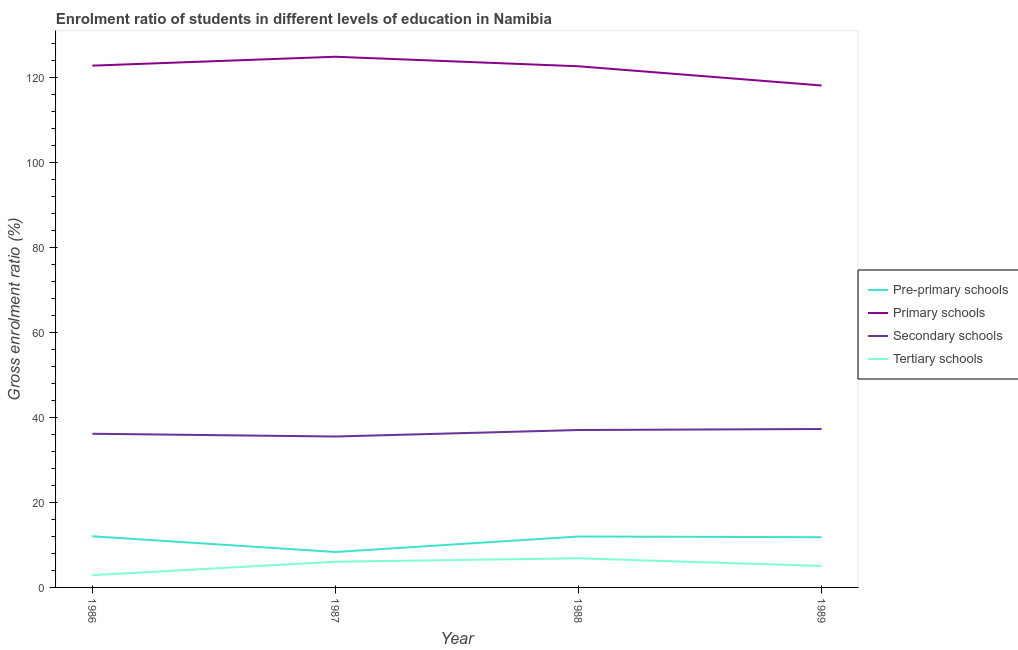How many different coloured lines are there?
Make the answer very short. 4. Does the line corresponding to gross enrolment ratio in primary schools intersect with the line corresponding to gross enrolment ratio in secondary schools?
Keep it short and to the point. No. What is the gross enrolment ratio in secondary schools in 1986?
Offer a very short reply. 36.14. Across all years, what is the maximum gross enrolment ratio in primary schools?
Provide a succinct answer. 124.79. Across all years, what is the minimum gross enrolment ratio in tertiary schools?
Provide a succinct answer. 2.88. In which year was the gross enrolment ratio in tertiary schools minimum?
Make the answer very short. 1986. What is the total gross enrolment ratio in primary schools in the graph?
Ensure brevity in your answer.  488.06. What is the difference between the gross enrolment ratio in pre-primary schools in 1986 and that in 1988?
Offer a terse response. 0.05. What is the difference between the gross enrolment ratio in pre-primary schools in 1989 and the gross enrolment ratio in primary schools in 1987?
Make the answer very short. -112.97. What is the average gross enrolment ratio in primary schools per year?
Provide a succinct answer. 122.01. In the year 1986, what is the difference between the gross enrolment ratio in pre-primary schools and gross enrolment ratio in secondary schools?
Your answer should be very brief. -24.11. What is the ratio of the gross enrolment ratio in secondary schools in 1986 to that in 1989?
Make the answer very short. 0.97. What is the difference between the highest and the second highest gross enrolment ratio in secondary schools?
Ensure brevity in your answer.  0.24. What is the difference between the highest and the lowest gross enrolment ratio in primary schools?
Provide a succinct answer. 6.76. Is the sum of the gross enrolment ratio in primary schools in 1987 and 1989 greater than the maximum gross enrolment ratio in pre-primary schools across all years?
Your answer should be very brief. Yes. Is it the case that in every year, the sum of the gross enrolment ratio in primary schools and gross enrolment ratio in tertiary schools is greater than the sum of gross enrolment ratio in pre-primary schools and gross enrolment ratio in secondary schools?
Provide a short and direct response. Yes. Is the gross enrolment ratio in pre-primary schools strictly greater than the gross enrolment ratio in primary schools over the years?
Offer a very short reply. No. How many years are there in the graph?
Keep it short and to the point. 4. What is the difference between two consecutive major ticks on the Y-axis?
Your answer should be compact. 20. Are the values on the major ticks of Y-axis written in scientific E-notation?
Provide a succinct answer. No. Does the graph contain any zero values?
Offer a terse response. No. Does the graph contain grids?
Provide a succinct answer. No. How many legend labels are there?
Your response must be concise. 4. What is the title of the graph?
Ensure brevity in your answer.  Enrolment ratio of students in different levels of education in Namibia. Does "Natural Gas" appear as one of the legend labels in the graph?
Offer a terse response. No. What is the label or title of the Y-axis?
Provide a succinct answer. Gross enrolment ratio (%). What is the Gross enrolment ratio (%) in Pre-primary schools in 1986?
Offer a very short reply. 12.03. What is the Gross enrolment ratio (%) of Primary schools in 1986?
Offer a very short reply. 122.7. What is the Gross enrolment ratio (%) of Secondary schools in 1986?
Your response must be concise. 36.14. What is the Gross enrolment ratio (%) of Tertiary schools in 1986?
Offer a very short reply. 2.88. What is the Gross enrolment ratio (%) of Pre-primary schools in 1987?
Provide a short and direct response. 8.33. What is the Gross enrolment ratio (%) of Primary schools in 1987?
Provide a succinct answer. 124.79. What is the Gross enrolment ratio (%) in Secondary schools in 1987?
Offer a terse response. 35.49. What is the Gross enrolment ratio (%) of Tertiary schools in 1987?
Offer a very short reply. 6.05. What is the Gross enrolment ratio (%) of Pre-primary schools in 1988?
Give a very brief answer. 11.97. What is the Gross enrolment ratio (%) of Primary schools in 1988?
Your answer should be compact. 122.55. What is the Gross enrolment ratio (%) in Secondary schools in 1988?
Ensure brevity in your answer.  37.01. What is the Gross enrolment ratio (%) of Tertiary schools in 1988?
Your response must be concise. 6.85. What is the Gross enrolment ratio (%) of Pre-primary schools in 1989?
Offer a terse response. 11.81. What is the Gross enrolment ratio (%) in Primary schools in 1989?
Give a very brief answer. 118.03. What is the Gross enrolment ratio (%) in Secondary schools in 1989?
Make the answer very short. 37.25. What is the Gross enrolment ratio (%) in Tertiary schools in 1989?
Give a very brief answer. 5.05. Across all years, what is the maximum Gross enrolment ratio (%) in Pre-primary schools?
Provide a succinct answer. 12.03. Across all years, what is the maximum Gross enrolment ratio (%) of Primary schools?
Ensure brevity in your answer.  124.79. Across all years, what is the maximum Gross enrolment ratio (%) of Secondary schools?
Provide a short and direct response. 37.25. Across all years, what is the maximum Gross enrolment ratio (%) in Tertiary schools?
Give a very brief answer. 6.85. Across all years, what is the minimum Gross enrolment ratio (%) of Pre-primary schools?
Provide a succinct answer. 8.33. Across all years, what is the minimum Gross enrolment ratio (%) of Primary schools?
Provide a short and direct response. 118.03. Across all years, what is the minimum Gross enrolment ratio (%) of Secondary schools?
Keep it short and to the point. 35.49. Across all years, what is the minimum Gross enrolment ratio (%) of Tertiary schools?
Offer a very short reply. 2.88. What is the total Gross enrolment ratio (%) of Pre-primary schools in the graph?
Ensure brevity in your answer.  44.14. What is the total Gross enrolment ratio (%) of Primary schools in the graph?
Ensure brevity in your answer.  488.06. What is the total Gross enrolment ratio (%) of Secondary schools in the graph?
Provide a succinct answer. 145.89. What is the total Gross enrolment ratio (%) of Tertiary schools in the graph?
Offer a very short reply. 20.82. What is the difference between the Gross enrolment ratio (%) in Pre-primary schools in 1986 and that in 1987?
Your response must be concise. 3.7. What is the difference between the Gross enrolment ratio (%) of Primary schools in 1986 and that in 1987?
Offer a terse response. -2.09. What is the difference between the Gross enrolment ratio (%) of Secondary schools in 1986 and that in 1987?
Offer a very short reply. 0.65. What is the difference between the Gross enrolment ratio (%) of Tertiary schools in 1986 and that in 1987?
Your answer should be compact. -3.16. What is the difference between the Gross enrolment ratio (%) in Pre-primary schools in 1986 and that in 1988?
Offer a terse response. 0.05. What is the difference between the Gross enrolment ratio (%) of Primary schools in 1986 and that in 1988?
Keep it short and to the point. 0.15. What is the difference between the Gross enrolment ratio (%) in Secondary schools in 1986 and that in 1988?
Make the answer very short. -0.88. What is the difference between the Gross enrolment ratio (%) of Tertiary schools in 1986 and that in 1988?
Your response must be concise. -3.97. What is the difference between the Gross enrolment ratio (%) of Pre-primary schools in 1986 and that in 1989?
Offer a terse response. 0.22. What is the difference between the Gross enrolment ratio (%) of Primary schools in 1986 and that in 1989?
Ensure brevity in your answer.  4.67. What is the difference between the Gross enrolment ratio (%) in Secondary schools in 1986 and that in 1989?
Make the answer very short. -1.12. What is the difference between the Gross enrolment ratio (%) of Tertiary schools in 1986 and that in 1989?
Your answer should be compact. -2.17. What is the difference between the Gross enrolment ratio (%) in Pre-primary schools in 1987 and that in 1988?
Offer a terse response. -3.64. What is the difference between the Gross enrolment ratio (%) of Primary schools in 1987 and that in 1988?
Your response must be concise. 2.24. What is the difference between the Gross enrolment ratio (%) in Secondary schools in 1987 and that in 1988?
Your answer should be very brief. -1.53. What is the difference between the Gross enrolment ratio (%) in Tertiary schools in 1987 and that in 1988?
Make the answer very short. -0.8. What is the difference between the Gross enrolment ratio (%) in Pre-primary schools in 1987 and that in 1989?
Your response must be concise. -3.48. What is the difference between the Gross enrolment ratio (%) of Primary schools in 1987 and that in 1989?
Offer a very short reply. 6.76. What is the difference between the Gross enrolment ratio (%) in Secondary schools in 1987 and that in 1989?
Offer a very short reply. -1.77. What is the difference between the Gross enrolment ratio (%) of Tertiary schools in 1987 and that in 1989?
Your answer should be very brief. 1. What is the difference between the Gross enrolment ratio (%) in Pre-primary schools in 1988 and that in 1989?
Provide a short and direct response. 0.16. What is the difference between the Gross enrolment ratio (%) of Primary schools in 1988 and that in 1989?
Provide a short and direct response. 4.52. What is the difference between the Gross enrolment ratio (%) of Secondary schools in 1988 and that in 1989?
Offer a very short reply. -0.24. What is the difference between the Gross enrolment ratio (%) in Tertiary schools in 1988 and that in 1989?
Your response must be concise. 1.8. What is the difference between the Gross enrolment ratio (%) in Pre-primary schools in 1986 and the Gross enrolment ratio (%) in Primary schools in 1987?
Make the answer very short. -112.76. What is the difference between the Gross enrolment ratio (%) in Pre-primary schools in 1986 and the Gross enrolment ratio (%) in Secondary schools in 1987?
Give a very brief answer. -23.46. What is the difference between the Gross enrolment ratio (%) of Pre-primary schools in 1986 and the Gross enrolment ratio (%) of Tertiary schools in 1987?
Offer a very short reply. 5.98. What is the difference between the Gross enrolment ratio (%) in Primary schools in 1986 and the Gross enrolment ratio (%) in Secondary schools in 1987?
Give a very brief answer. 87.21. What is the difference between the Gross enrolment ratio (%) in Primary schools in 1986 and the Gross enrolment ratio (%) in Tertiary schools in 1987?
Provide a short and direct response. 116.65. What is the difference between the Gross enrolment ratio (%) in Secondary schools in 1986 and the Gross enrolment ratio (%) in Tertiary schools in 1987?
Ensure brevity in your answer.  30.09. What is the difference between the Gross enrolment ratio (%) in Pre-primary schools in 1986 and the Gross enrolment ratio (%) in Primary schools in 1988?
Your answer should be compact. -110.52. What is the difference between the Gross enrolment ratio (%) in Pre-primary schools in 1986 and the Gross enrolment ratio (%) in Secondary schools in 1988?
Make the answer very short. -24.99. What is the difference between the Gross enrolment ratio (%) in Pre-primary schools in 1986 and the Gross enrolment ratio (%) in Tertiary schools in 1988?
Offer a terse response. 5.18. What is the difference between the Gross enrolment ratio (%) of Primary schools in 1986 and the Gross enrolment ratio (%) of Secondary schools in 1988?
Give a very brief answer. 85.68. What is the difference between the Gross enrolment ratio (%) in Primary schools in 1986 and the Gross enrolment ratio (%) in Tertiary schools in 1988?
Provide a short and direct response. 115.85. What is the difference between the Gross enrolment ratio (%) in Secondary schools in 1986 and the Gross enrolment ratio (%) in Tertiary schools in 1988?
Ensure brevity in your answer.  29.29. What is the difference between the Gross enrolment ratio (%) in Pre-primary schools in 1986 and the Gross enrolment ratio (%) in Primary schools in 1989?
Your answer should be very brief. -106. What is the difference between the Gross enrolment ratio (%) in Pre-primary schools in 1986 and the Gross enrolment ratio (%) in Secondary schools in 1989?
Provide a succinct answer. -25.22. What is the difference between the Gross enrolment ratio (%) in Pre-primary schools in 1986 and the Gross enrolment ratio (%) in Tertiary schools in 1989?
Offer a very short reply. 6.98. What is the difference between the Gross enrolment ratio (%) of Primary schools in 1986 and the Gross enrolment ratio (%) of Secondary schools in 1989?
Offer a very short reply. 85.44. What is the difference between the Gross enrolment ratio (%) in Primary schools in 1986 and the Gross enrolment ratio (%) in Tertiary schools in 1989?
Give a very brief answer. 117.65. What is the difference between the Gross enrolment ratio (%) of Secondary schools in 1986 and the Gross enrolment ratio (%) of Tertiary schools in 1989?
Give a very brief answer. 31.09. What is the difference between the Gross enrolment ratio (%) in Pre-primary schools in 1987 and the Gross enrolment ratio (%) in Primary schools in 1988?
Make the answer very short. -114.22. What is the difference between the Gross enrolment ratio (%) of Pre-primary schools in 1987 and the Gross enrolment ratio (%) of Secondary schools in 1988?
Make the answer very short. -28.68. What is the difference between the Gross enrolment ratio (%) in Pre-primary schools in 1987 and the Gross enrolment ratio (%) in Tertiary schools in 1988?
Keep it short and to the point. 1.48. What is the difference between the Gross enrolment ratio (%) of Primary schools in 1987 and the Gross enrolment ratio (%) of Secondary schools in 1988?
Your answer should be compact. 87.77. What is the difference between the Gross enrolment ratio (%) in Primary schools in 1987 and the Gross enrolment ratio (%) in Tertiary schools in 1988?
Your answer should be compact. 117.94. What is the difference between the Gross enrolment ratio (%) in Secondary schools in 1987 and the Gross enrolment ratio (%) in Tertiary schools in 1988?
Your response must be concise. 28.64. What is the difference between the Gross enrolment ratio (%) in Pre-primary schools in 1987 and the Gross enrolment ratio (%) in Primary schools in 1989?
Ensure brevity in your answer.  -109.7. What is the difference between the Gross enrolment ratio (%) of Pre-primary schools in 1987 and the Gross enrolment ratio (%) of Secondary schools in 1989?
Provide a short and direct response. -28.92. What is the difference between the Gross enrolment ratio (%) of Pre-primary schools in 1987 and the Gross enrolment ratio (%) of Tertiary schools in 1989?
Give a very brief answer. 3.28. What is the difference between the Gross enrolment ratio (%) of Primary schools in 1987 and the Gross enrolment ratio (%) of Secondary schools in 1989?
Your response must be concise. 87.53. What is the difference between the Gross enrolment ratio (%) in Primary schools in 1987 and the Gross enrolment ratio (%) in Tertiary schools in 1989?
Provide a succinct answer. 119.74. What is the difference between the Gross enrolment ratio (%) in Secondary schools in 1987 and the Gross enrolment ratio (%) in Tertiary schools in 1989?
Provide a short and direct response. 30.44. What is the difference between the Gross enrolment ratio (%) of Pre-primary schools in 1988 and the Gross enrolment ratio (%) of Primary schools in 1989?
Make the answer very short. -106.05. What is the difference between the Gross enrolment ratio (%) in Pre-primary schools in 1988 and the Gross enrolment ratio (%) in Secondary schools in 1989?
Your answer should be compact. -25.28. What is the difference between the Gross enrolment ratio (%) in Pre-primary schools in 1988 and the Gross enrolment ratio (%) in Tertiary schools in 1989?
Keep it short and to the point. 6.92. What is the difference between the Gross enrolment ratio (%) in Primary schools in 1988 and the Gross enrolment ratio (%) in Secondary schools in 1989?
Your answer should be compact. 85.29. What is the difference between the Gross enrolment ratio (%) in Primary schools in 1988 and the Gross enrolment ratio (%) in Tertiary schools in 1989?
Your answer should be compact. 117.5. What is the difference between the Gross enrolment ratio (%) of Secondary schools in 1988 and the Gross enrolment ratio (%) of Tertiary schools in 1989?
Ensure brevity in your answer.  31.96. What is the average Gross enrolment ratio (%) of Pre-primary schools per year?
Provide a succinct answer. 11.04. What is the average Gross enrolment ratio (%) of Primary schools per year?
Provide a succinct answer. 122.01. What is the average Gross enrolment ratio (%) in Secondary schools per year?
Your answer should be very brief. 36.47. What is the average Gross enrolment ratio (%) of Tertiary schools per year?
Your answer should be very brief. 5.21. In the year 1986, what is the difference between the Gross enrolment ratio (%) in Pre-primary schools and Gross enrolment ratio (%) in Primary schools?
Keep it short and to the point. -110.67. In the year 1986, what is the difference between the Gross enrolment ratio (%) in Pre-primary schools and Gross enrolment ratio (%) in Secondary schools?
Give a very brief answer. -24.11. In the year 1986, what is the difference between the Gross enrolment ratio (%) in Pre-primary schools and Gross enrolment ratio (%) in Tertiary schools?
Offer a terse response. 9.15. In the year 1986, what is the difference between the Gross enrolment ratio (%) in Primary schools and Gross enrolment ratio (%) in Secondary schools?
Keep it short and to the point. 86.56. In the year 1986, what is the difference between the Gross enrolment ratio (%) of Primary schools and Gross enrolment ratio (%) of Tertiary schools?
Offer a very short reply. 119.81. In the year 1986, what is the difference between the Gross enrolment ratio (%) of Secondary schools and Gross enrolment ratio (%) of Tertiary schools?
Make the answer very short. 33.26. In the year 1987, what is the difference between the Gross enrolment ratio (%) in Pre-primary schools and Gross enrolment ratio (%) in Primary schools?
Your answer should be compact. -116.46. In the year 1987, what is the difference between the Gross enrolment ratio (%) in Pre-primary schools and Gross enrolment ratio (%) in Secondary schools?
Your answer should be very brief. -27.16. In the year 1987, what is the difference between the Gross enrolment ratio (%) of Pre-primary schools and Gross enrolment ratio (%) of Tertiary schools?
Keep it short and to the point. 2.28. In the year 1987, what is the difference between the Gross enrolment ratio (%) of Primary schools and Gross enrolment ratio (%) of Secondary schools?
Give a very brief answer. 89.3. In the year 1987, what is the difference between the Gross enrolment ratio (%) of Primary schools and Gross enrolment ratio (%) of Tertiary schools?
Provide a short and direct response. 118.74. In the year 1987, what is the difference between the Gross enrolment ratio (%) in Secondary schools and Gross enrolment ratio (%) in Tertiary schools?
Your response must be concise. 29.44. In the year 1988, what is the difference between the Gross enrolment ratio (%) of Pre-primary schools and Gross enrolment ratio (%) of Primary schools?
Ensure brevity in your answer.  -110.57. In the year 1988, what is the difference between the Gross enrolment ratio (%) in Pre-primary schools and Gross enrolment ratio (%) in Secondary schools?
Keep it short and to the point. -25.04. In the year 1988, what is the difference between the Gross enrolment ratio (%) in Pre-primary schools and Gross enrolment ratio (%) in Tertiary schools?
Offer a very short reply. 5.13. In the year 1988, what is the difference between the Gross enrolment ratio (%) of Primary schools and Gross enrolment ratio (%) of Secondary schools?
Your answer should be compact. 85.53. In the year 1988, what is the difference between the Gross enrolment ratio (%) of Primary schools and Gross enrolment ratio (%) of Tertiary schools?
Your answer should be very brief. 115.7. In the year 1988, what is the difference between the Gross enrolment ratio (%) of Secondary schools and Gross enrolment ratio (%) of Tertiary schools?
Offer a very short reply. 30.17. In the year 1989, what is the difference between the Gross enrolment ratio (%) in Pre-primary schools and Gross enrolment ratio (%) in Primary schools?
Keep it short and to the point. -106.22. In the year 1989, what is the difference between the Gross enrolment ratio (%) of Pre-primary schools and Gross enrolment ratio (%) of Secondary schools?
Offer a very short reply. -25.44. In the year 1989, what is the difference between the Gross enrolment ratio (%) of Pre-primary schools and Gross enrolment ratio (%) of Tertiary schools?
Ensure brevity in your answer.  6.76. In the year 1989, what is the difference between the Gross enrolment ratio (%) in Primary schools and Gross enrolment ratio (%) in Secondary schools?
Your answer should be compact. 80.78. In the year 1989, what is the difference between the Gross enrolment ratio (%) of Primary schools and Gross enrolment ratio (%) of Tertiary schools?
Provide a short and direct response. 112.98. In the year 1989, what is the difference between the Gross enrolment ratio (%) of Secondary schools and Gross enrolment ratio (%) of Tertiary schools?
Your answer should be compact. 32.2. What is the ratio of the Gross enrolment ratio (%) in Pre-primary schools in 1986 to that in 1987?
Your response must be concise. 1.44. What is the ratio of the Gross enrolment ratio (%) of Primary schools in 1986 to that in 1987?
Keep it short and to the point. 0.98. What is the ratio of the Gross enrolment ratio (%) in Secondary schools in 1986 to that in 1987?
Offer a very short reply. 1.02. What is the ratio of the Gross enrolment ratio (%) of Tertiary schools in 1986 to that in 1987?
Provide a succinct answer. 0.48. What is the ratio of the Gross enrolment ratio (%) of Pre-primary schools in 1986 to that in 1988?
Your response must be concise. 1. What is the ratio of the Gross enrolment ratio (%) of Primary schools in 1986 to that in 1988?
Your answer should be very brief. 1. What is the ratio of the Gross enrolment ratio (%) of Secondary schools in 1986 to that in 1988?
Offer a very short reply. 0.98. What is the ratio of the Gross enrolment ratio (%) of Tertiary schools in 1986 to that in 1988?
Keep it short and to the point. 0.42. What is the ratio of the Gross enrolment ratio (%) of Pre-primary schools in 1986 to that in 1989?
Offer a terse response. 1.02. What is the ratio of the Gross enrolment ratio (%) of Primary schools in 1986 to that in 1989?
Offer a terse response. 1.04. What is the ratio of the Gross enrolment ratio (%) in Secondary schools in 1986 to that in 1989?
Your response must be concise. 0.97. What is the ratio of the Gross enrolment ratio (%) of Tertiary schools in 1986 to that in 1989?
Provide a succinct answer. 0.57. What is the ratio of the Gross enrolment ratio (%) of Pre-primary schools in 1987 to that in 1988?
Provide a short and direct response. 0.7. What is the ratio of the Gross enrolment ratio (%) in Primary schools in 1987 to that in 1988?
Make the answer very short. 1.02. What is the ratio of the Gross enrolment ratio (%) of Secondary schools in 1987 to that in 1988?
Your response must be concise. 0.96. What is the ratio of the Gross enrolment ratio (%) in Tertiary schools in 1987 to that in 1988?
Provide a short and direct response. 0.88. What is the ratio of the Gross enrolment ratio (%) in Pre-primary schools in 1987 to that in 1989?
Provide a succinct answer. 0.71. What is the ratio of the Gross enrolment ratio (%) of Primary schools in 1987 to that in 1989?
Offer a terse response. 1.06. What is the ratio of the Gross enrolment ratio (%) in Secondary schools in 1987 to that in 1989?
Offer a terse response. 0.95. What is the ratio of the Gross enrolment ratio (%) of Tertiary schools in 1987 to that in 1989?
Provide a succinct answer. 1.2. What is the ratio of the Gross enrolment ratio (%) of Pre-primary schools in 1988 to that in 1989?
Your answer should be very brief. 1.01. What is the ratio of the Gross enrolment ratio (%) in Primary schools in 1988 to that in 1989?
Your answer should be compact. 1.04. What is the ratio of the Gross enrolment ratio (%) in Tertiary schools in 1988 to that in 1989?
Ensure brevity in your answer.  1.36. What is the difference between the highest and the second highest Gross enrolment ratio (%) of Pre-primary schools?
Keep it short and to the point. 0.05. What is the difference between the highest and the second highest Gross enrolment ratio (%) of Primary schools?
Make the answer very short. 2.09. What is the difference between the highest and the second highest Gross enrolment ratio (%) in Secondary schools?
Provide a short and direct response. 0.24. What is the difference between the highest and the second highest Gross enrolment ratio (%) in Tertiary schools?
Give a very brief answer. 0.8. What is the difference between the highest and the lowest Gross enrolment ratio (%) in Pre-primary schools?
Provide a short and direct response. 3.7. What is the difference between the highest and the lowest Gross enrolment ratio (%) of Primary schools?
Provide a succinct answer. 6.76. What is the difference between the highest and the lowest Gross enrolment ratio (%) of Secondary schools?
Give a very brief answer. 1.77. What is the difference between the highest and the lowest Gross enrolment ratio (%) in Tertiary schools?
Your response must be concise. 3.97. 